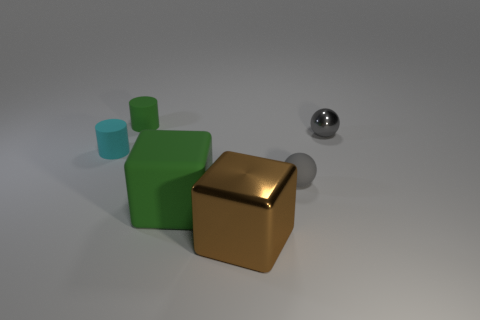What number of large green matte cubes are in front of the green rubber object that is behind the big cube that is left of the large brown metal cube?
Provide a succinct answer. 1. There is a cylinder that is the same color as the large rubber object; what is it made of?
Your response must be concise. Rubber. What number of cubes are there?
Your answer should be very brief. 2. There is a cylinder in front of the gray metal ball; is it the same size as the tiny shiny sphere?
Offer a very short reply. Yes. What number of matte objects are either big objects or cyan cylinders?
Your response must be concise. 2. What number of small green matte objects are right of the large cube on the left side of the brown metal cube?
Offer a terse response. 0. The small matte object that is to the left of the big brown cube and on the right side of the small cyan rubber cylinder has what shape?
Ensure brevity in your answer.  Cylinder. What material is the tiny cylinder that is on the left side of the green rubber thing that is behind the green thing that is to the right of the small green matte cylinder made of?
Your response must be concise. Rubber. What is the size of the cylinder that is the same color as the matte block?
Offer a terse response. Small. What material is the tiny cyan cylinder?
Provide a short and direct response. Rubber. 